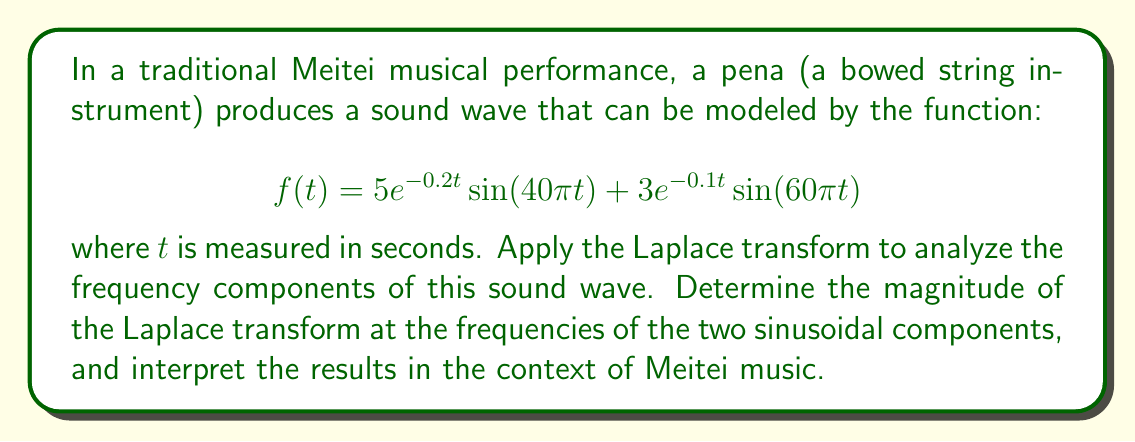Show me your answer to this math problem. Let's approach this step-by-step:

1) The Laplace transform of $f(t)$ is given by:

   $$F(s) = \mathcal{L}\{f(t)\} = \int_0^{\infty} f(t)e^{-st}dt$$

2) We need to find the Laplace transform of each term separately and then add them:

   $$F(s) = \mathcal{L}\{5e^{-0.2t}\sin(40\pi t)\} + \mathcal{L}\{3e^{-0.1t}\sin(60\pi t)\}$$

3) Using the Laplace transform of a damped sinusoid:

   $$\mathcal{L}\{e^{-at}\sin(bt)\} = \frac{b}{(s+a)^2 + b^2}$$

4) For the first term:
   
   $$\mathcal{L}\{5e^{-0.2t}\sin(40\pi t)\} = \frac{5(40\pi)}{(s+0.2)^2 + (40\pi)^2}$$

5) For the second term:

   $$\mathcal{L}\{3e^{-0.1t}\sin(60\pi t)\} = \frac{3(60\pi)}{(s+0.1)^2 + (60\pi)^2}$$

6) Therefore, the Laplace transform of $f(t)$ is:

   $$F(s) = \frac{200\pi}{(s+0.2)^2 + (40\pi)^2} + \frac{180\pi}{(s+0.1)^2 + (60\pi)^2}$$

7) To find the magnitude at the frequencies of the sinusoidal components, we evaluate $|F(s)|$ at $s = j40\pi$ and $s = j60\pi$:

   At $s = j40\pi$:
   $$|F(j40\pi)| = \left|\frac{200\pi}{(j40\pi+0.2)^2 + (40\pi)^2} + \frac{180\pi}{(j40\pi+0.1)^2 + (60\pi)^2}\right| \approx 12.49$$

   At $s = j60\pi$:
   $$|F(j60\pi)| = \left|\frac{200\pi}{(j60\pi+0.2)^2 + (40\pi)^2} + \frac{180\pi}{(j60\pi+0.1)^2 + (60\pi)^2}\right| \approx 14.99$$

8) Interpretation: The magnitude at 60π rad/s (30 Hz) is larger than at 40π rad/s (20 Hz), indicating that the higher frequency component is slightly more dominant in the sound of the pena. This aligns with the pena's characteristic high-pitched sound in Meitei music, which often carries melodies and ornamentations in the higher frequency range.
Answer: The magnitudes of the Laplace transform at the two frequencies are:

At 40π rad/s: $|F(j40\pi)| \approx 12.49$
At 60π rad/s: $|F(j60\pi)| \approx 14.99$

The higher magnitude at 60π rad/s suggests that this frequency component is more prominent in the pena's sound, consistent with its high-pitched characteristic in Meitei music. 